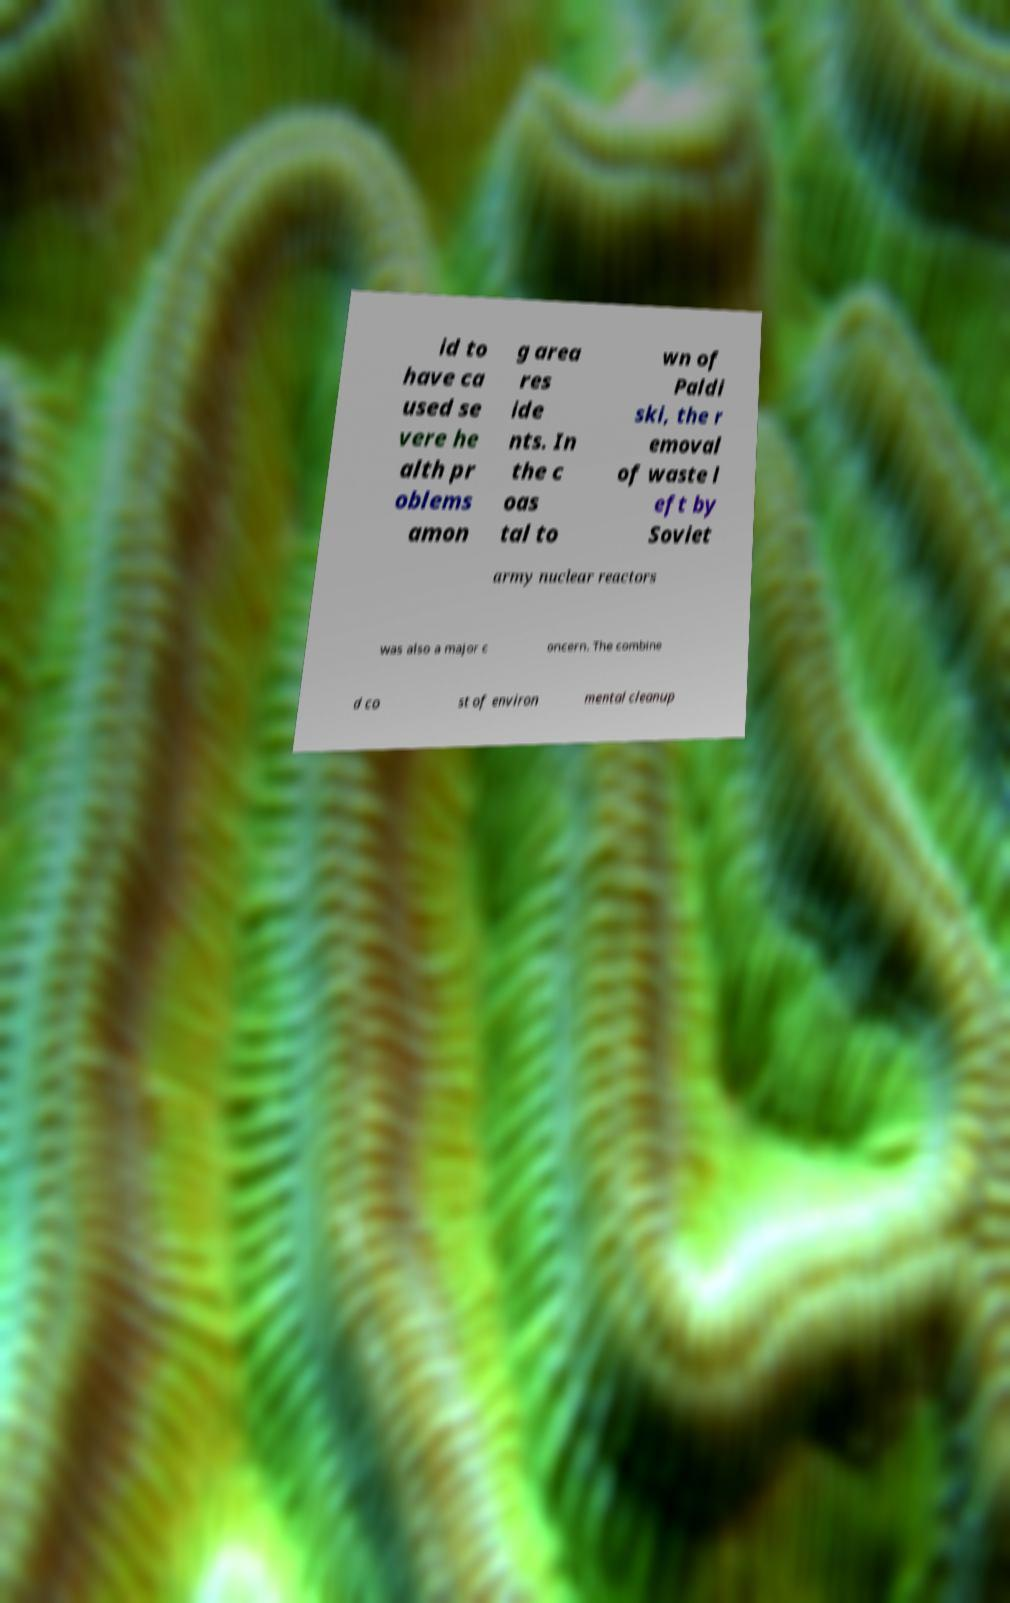For documentation purposes, I need the text within this image transcribed. Could you provide that? id to have ca used se vere he alth pr oblems amon g area res ide nts. In the c oas tal to wn of Paldi ski, the r emoval of waste l eft by Soviet army nuclear reactors was also a major c oncern. The combine d co st of environ mental cleanup 